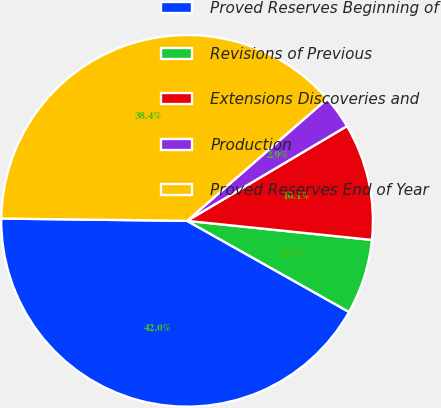Convert chart to OTSL. <chart><loc_0><loc_0><loc_500><loc_500><pie_chart><fcel>Proved Reserves Beginning of<fcel>Revisions of Previous<fcel>Extensions Discoveries and<fcel>Production<fcel>Proved Reserves End of Year<nl><fcel>42.04%<fcel>6.52%<fcel>10.15%<fcel>2.89%<fcel>38.4%<nl></chart> 